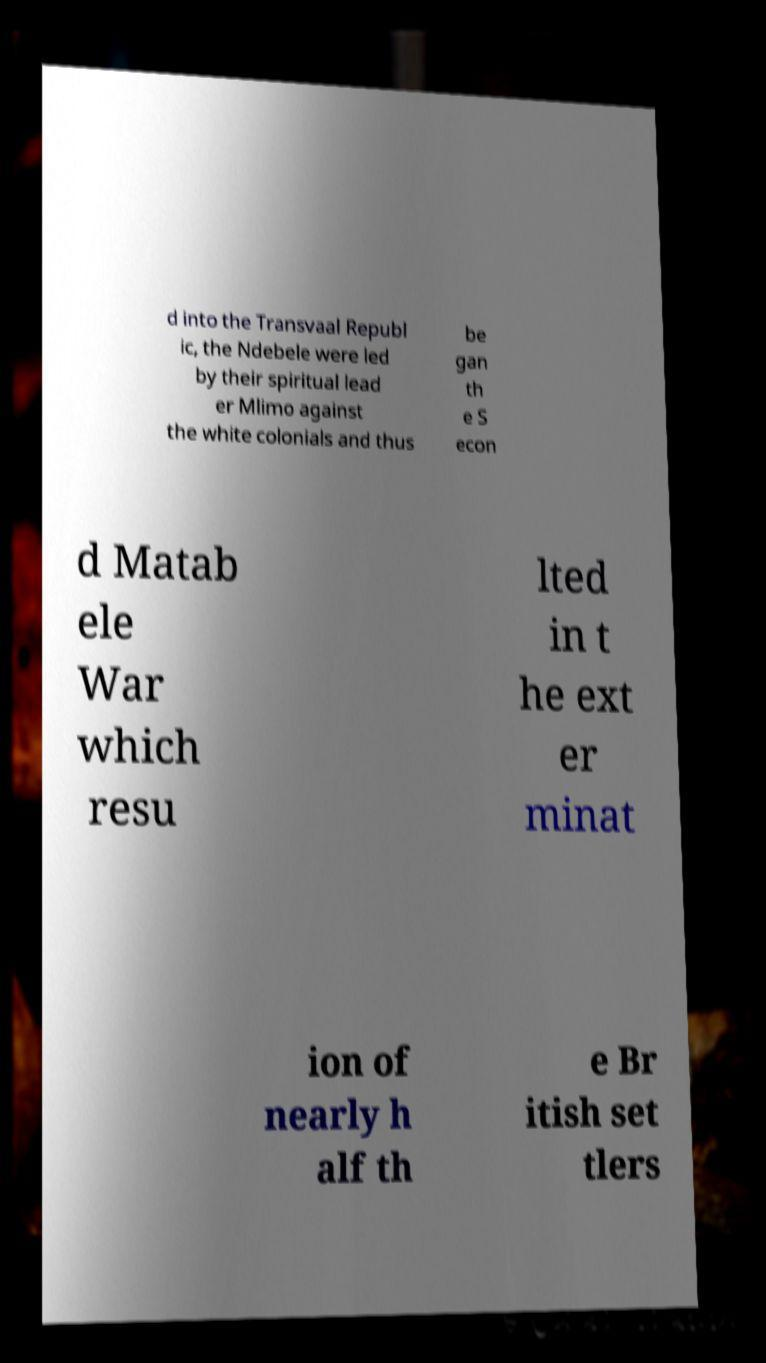What can you tell about the significance of Mlimo in this conflict? Mlimo played a crucial role as the spiritual leader of the Ndebele people during the Second Matabele War. He inspired the Ndebele to resist the British South Africa Company's colonization attempts. Mlimo's leadership was pivotal in mobilizing the Ndebele and shaping their strategies, although it ultimately led to tragic consequences for the Ndebele population. 